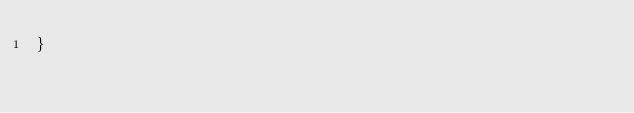<code> <loc_0><loc_0><loc_500><loc_500><_CSS_>}</code> 